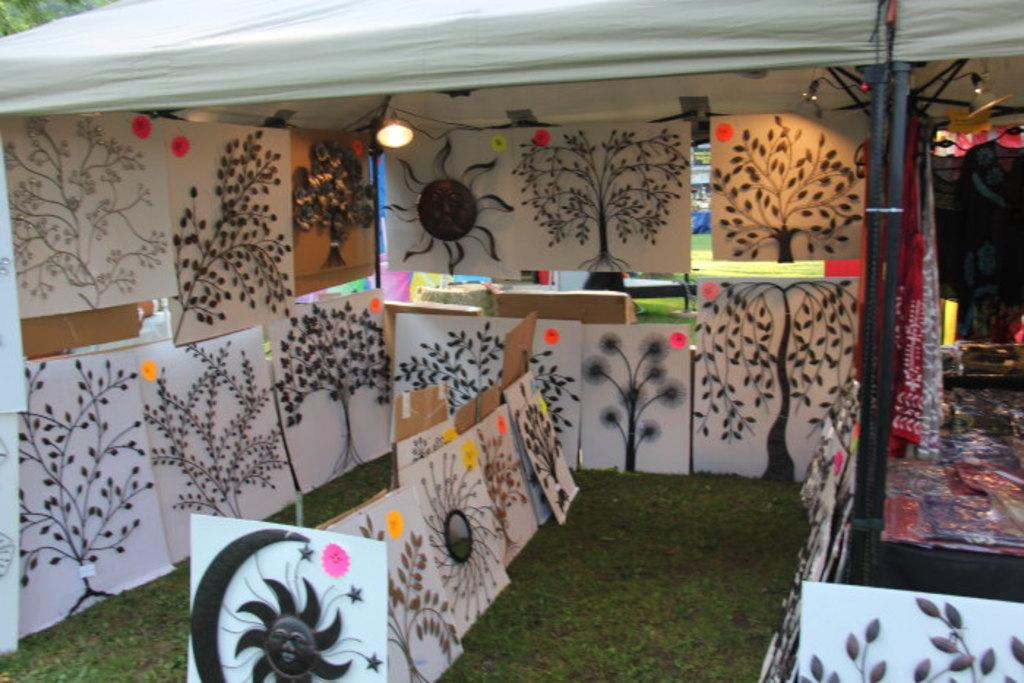What type of materials can be found in the stall? There are drawing papers in the stall. What is covering the table in the image? There are plastic covers on the table. Where are the lights located in the image? The lights are at the top of the image. What type of dinner is being served in the image? There is no dinner present in the image; it features drawing papers, plastic covers, and lights. Is there a club visible in the image? There is no club present in the image. 